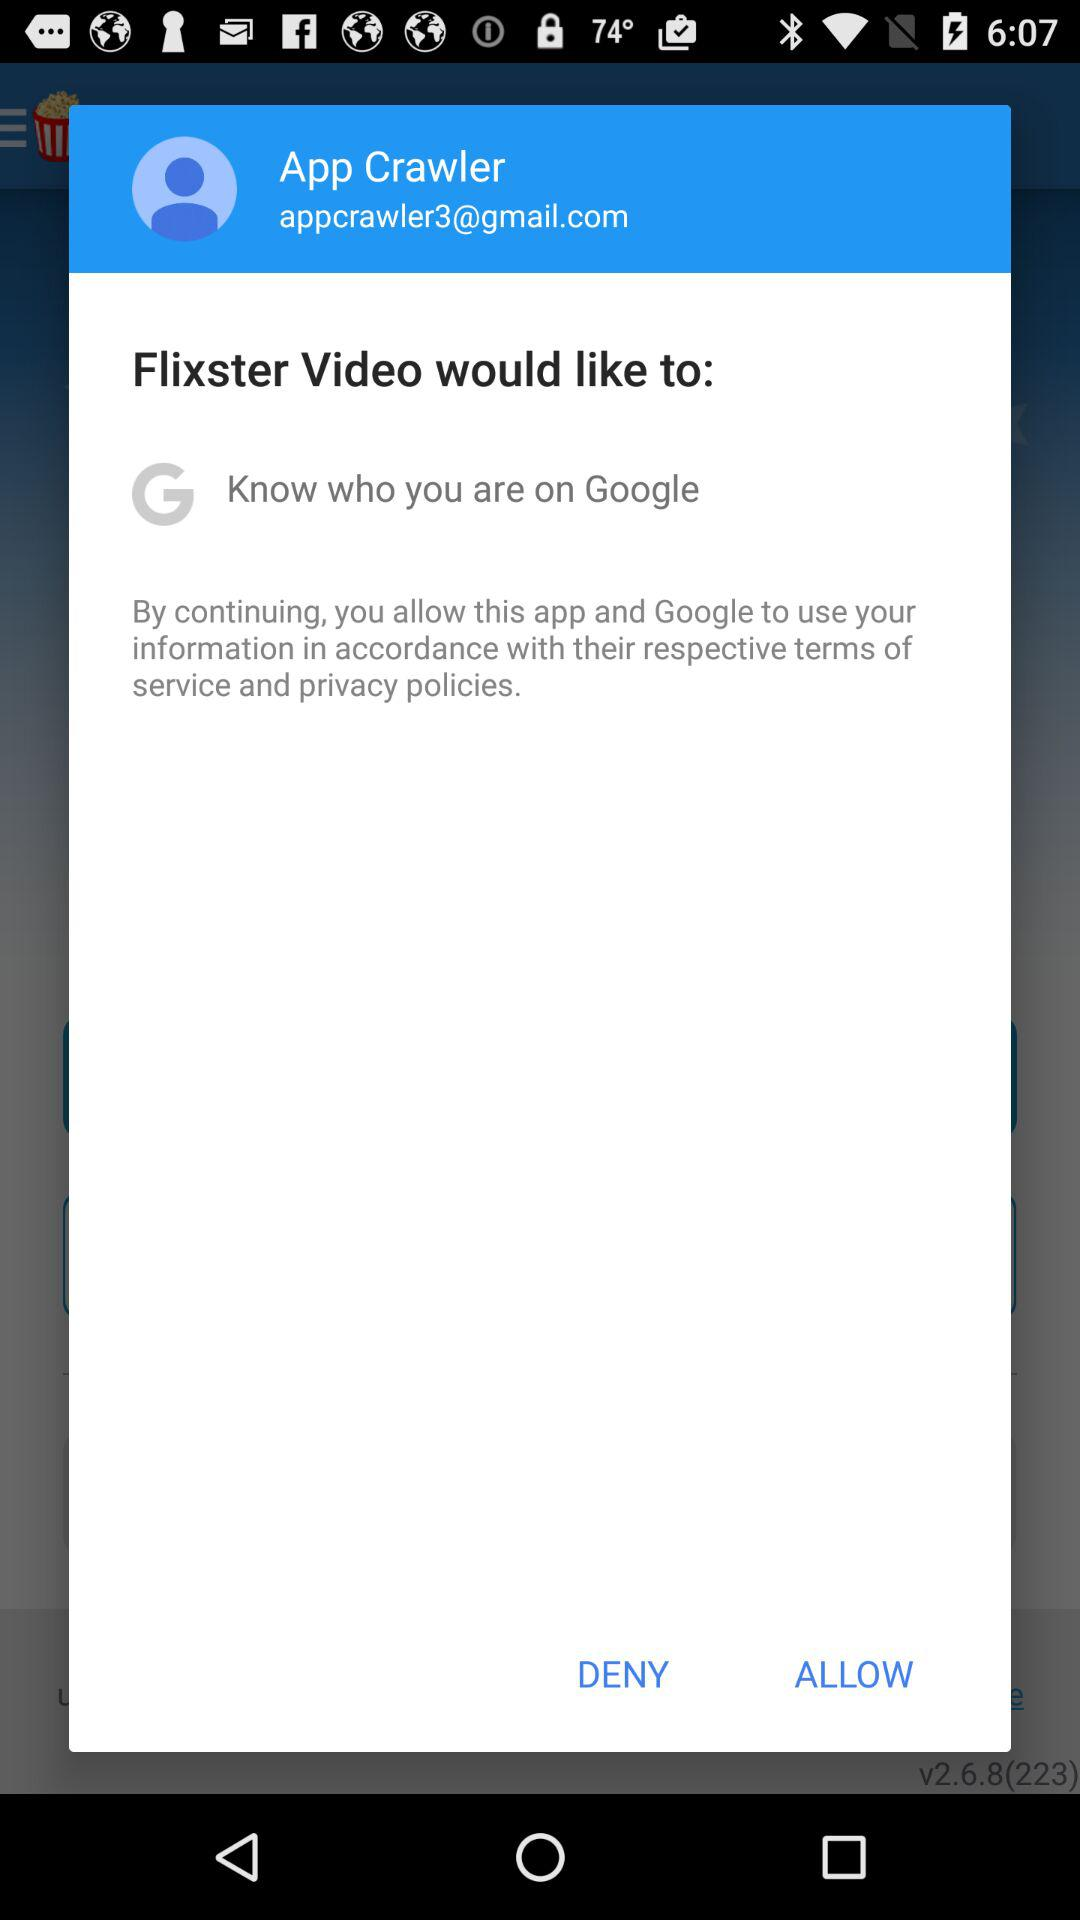What is the given profile name? The given profile name is App Crawler. 